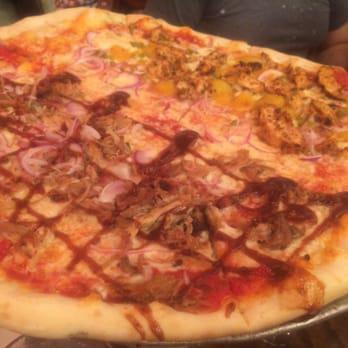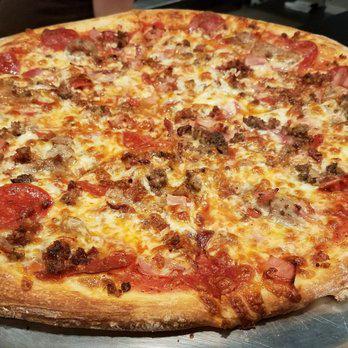The first image is the image on the left, the second image is the image on the right. Considering the images on both sides, is "The left pizza has something green on it." valid? Answer yes or no. No. The first image is the image on the left, the second image is the image on the right. Evaluate the accuracy of this statement regarding the images: "There are two pizza that are perfect circles.". Is it true? Answer yes or no. No. 